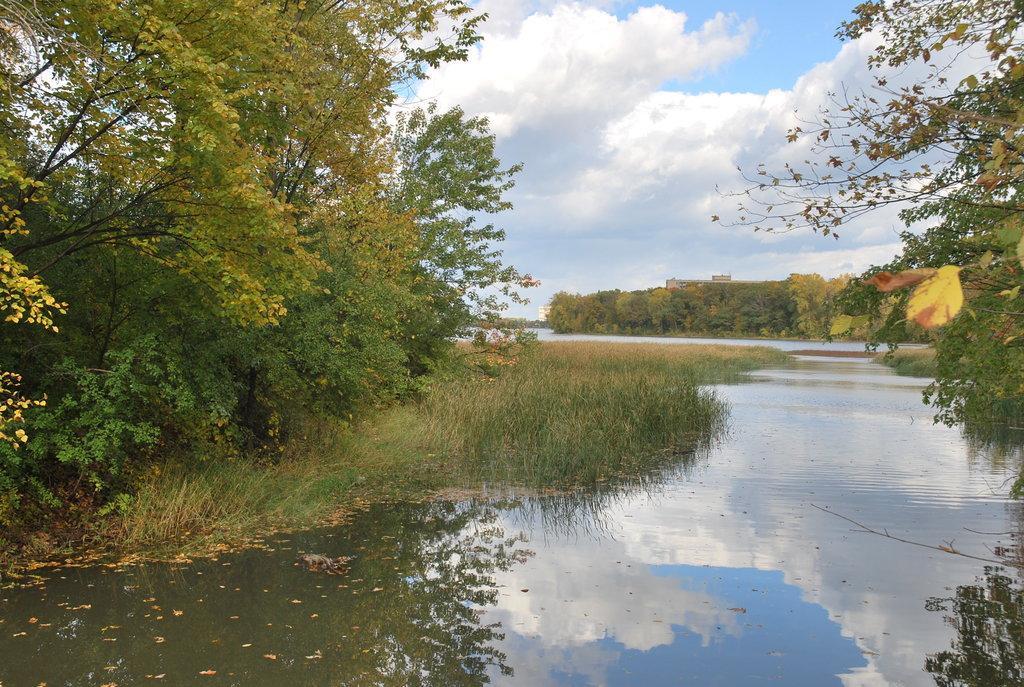Please provide a concise description of this image. In this image we can see there are trees, grass, water, and building. And at the top there is a cloudy sky. 